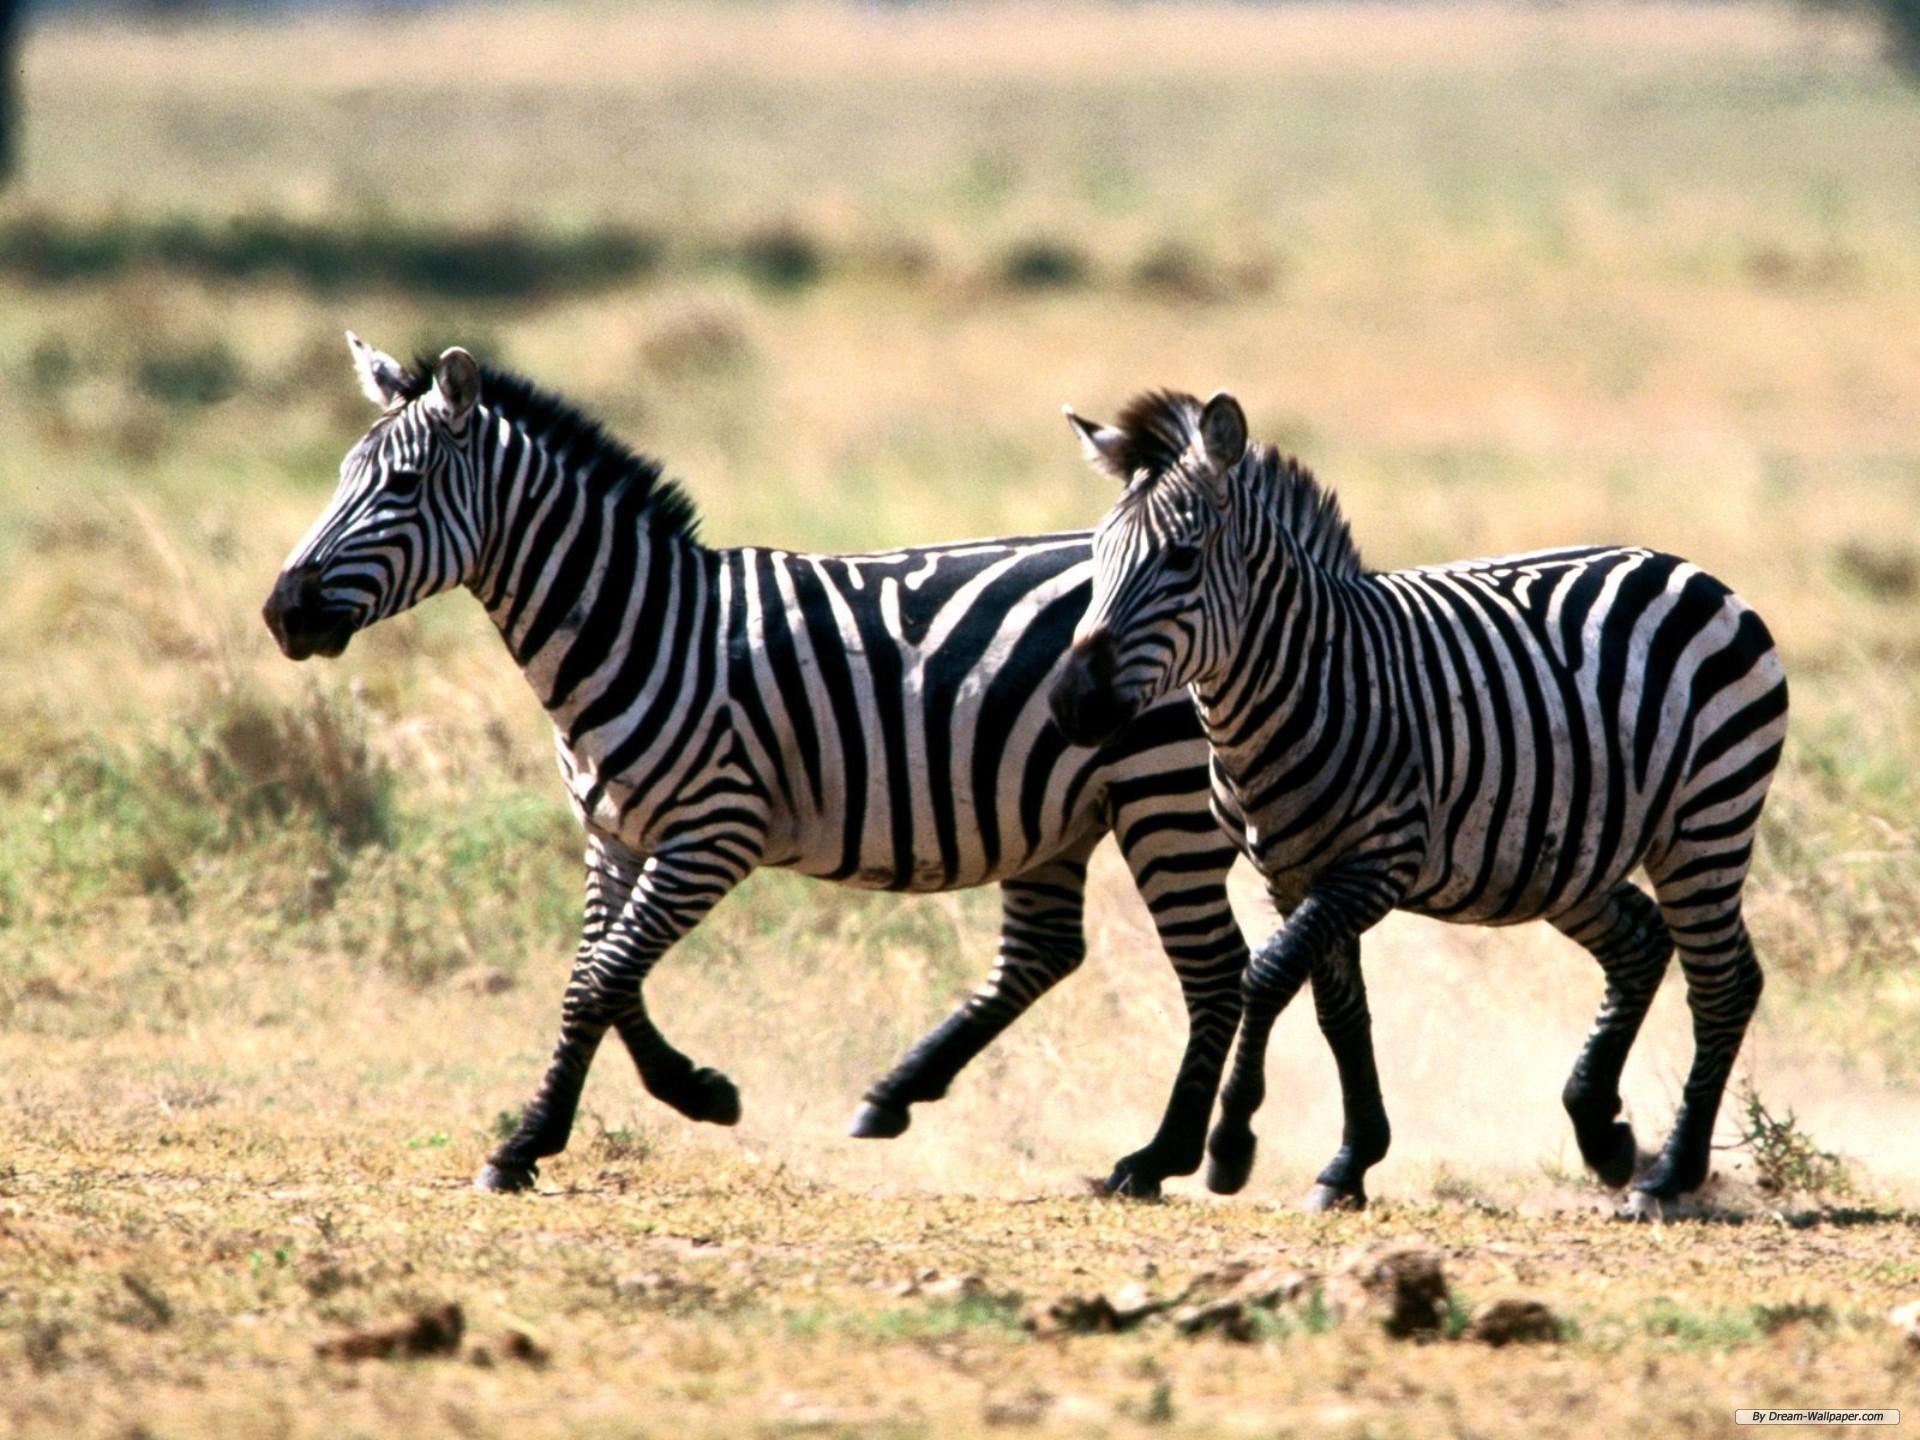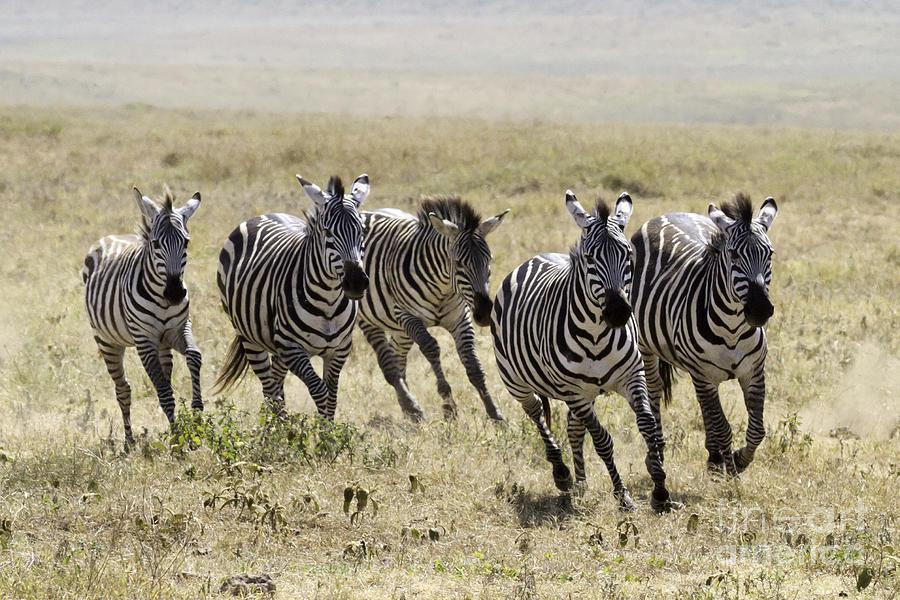The first image is the image on the left, the second image is the image on the right. For the images shown, is this caption "There are two zebras next to each other moving left and forward." true? Answer yes or no. Yes. The first image is the image on the left, the second image is the image on the right. Given the left and right images, does the statement "One image shows at least four zebras running forward, and the other image shows at least two zebras running leftward." hold true? Answer yes or no. Yes. 